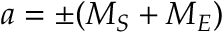<formula> <loc_0><loc_0><loc_500><loc_500>a = \pm ( M _ { S } + M _ { E } )</formula> 